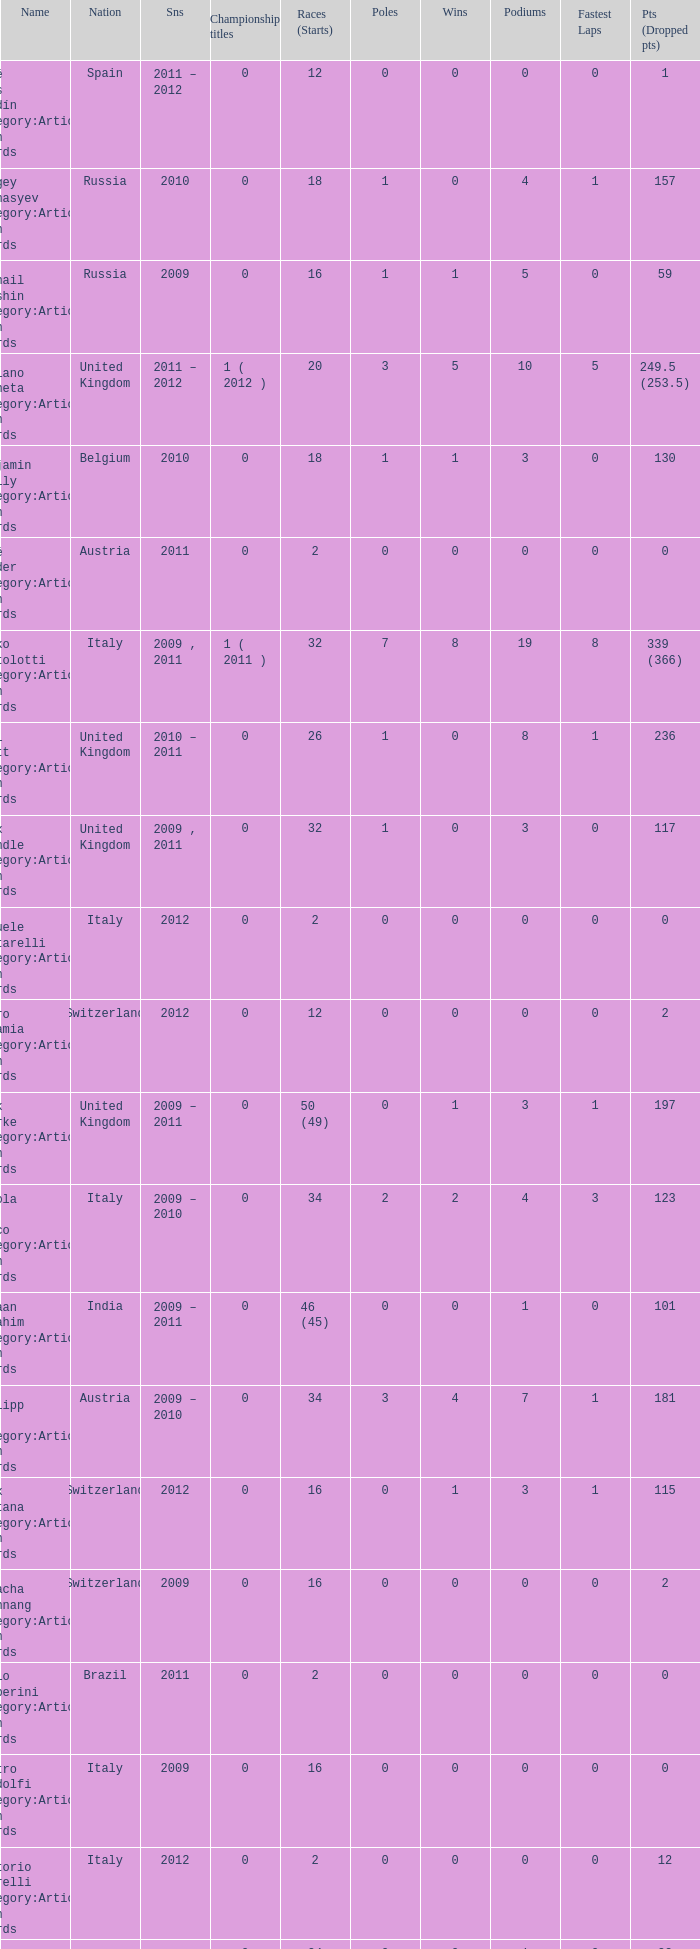What is the minimum amount of poles? 0.0. Help me parse the entirety of this table. {'header': ['Name', 'Nation', 'Sns', 'Championship titles', 'Races (Starts)', 'Poles', 'Wins', 'Podiums', 'Fastest Laps', 'Pts (Dropped pts)'], 'rows': [['José Luis Abadín Category:Articles with hCards', 'Spain', '2011 – 2012', '0', '12', '0', '0', '0', '0', '1'], ['Sergey Afanasyev Category:Articles with hCards', 'Russia', '2010', '0', '18', '1', '0', '4', '1', '157'], ['Mikhail Aleshin Category:Articles with hCards', 'Russia', '2009', '0', '16', '1', '1', '5', '0', '59'], ['Luciano Bacheta Category:Articles with hCards', 'United Kingdom', '2011 – 2012', '1 ( 2012 )', '20', '3', '5', '10', '5', '249.5 (253.5)'], ['Benjamin Bailly Category:Articles with hCards', 'Belgium', '2010', '0', '18', '1', '1', '3', '0', '130'], ['René Binder Category:Articles with hCards', 'Austria', '2011', '0', '2', '0', '0', '0', '0', '0'], ['Mirko Bortolotti Category:Articles with hCards', 'Italy', '2009 , 2011', '1 ( 2011 )', '32', '7', '8', '19', '8', '339 (366)'], ['Will Bratt Category:Articles with hCards', 'United Kingdom', '2010 – 2011', '0', '26', '1', '0', '8', '1', '236'], ['Alex Brundle Category:Articles with hCards', 'United Kingdom', '2009 , 2011', '0', '32', '1', '0', '3', '0', '117'], ['Samuele Buttarelli Category:Articles with hCards', 'Italy', '2012', '0', '2', '0', '0', '0', '0', '0'], ['Mauro Calamia Category:Articles with hCards', 'Switzerland', '2012', '0', '12', '0', '0', '0', '0', '2'], ['Jack Clarke Category:Articles with hCards', 'United Kingdom', '2009 – 2011', '0', '50 (49)', '0', '1', '3', '1', '197'], ['Nicola de Marco Category:Articles with hCards', 'Italy', '2009 – 2010', '0', '34', '2', '2', '4', '3', '123'], ['Armaan Ebrahim Category:Articles with hCards', 'India', '2009 – 2011', '0', '46 (45)', '0', '0', '1', '0', '101'], ['Philipp Eng Category:Articles with hCards', 'Austria', '2009 – 2010', '0', '34', '3', '4', '7', '1', '181'], ['Alex Fontana Category:Articles with hCards', 'Switzerland', '2012', '0', '16', '0', '1', '3', '1', '115'], ['Natacha Gachnang Category:Articles with hCards', 'Switzerland', '2009', '0', '16', '0', '0', '0', '0', '2'], ['Fabio Gamberini Category:Articles with hCards', 'Brazil', '2011', '0', '2', '0', '0', '0', '0', '0'], ['Pietro Gandolfi Category:Articles with hCards', 'Italy', '2009', '0', '16', '0', '0', '0', '0', '0'], ['Vittorio Ghirelli Category:Articles with hCards', 'Italy', '2012', '0', '2', '0', '0', '0', '0', '12'], ['Tom Gladdis Category:Articles with hCards', 'United Kingdom', '2009 – 2011', '0', '24', '0', '0', '1', '0', '33'], ['Richard Gonda Category:Articles with hCards', 'Slovakia', '2012', '0', '2', '0', '0', '0', '0', '4'], ['Victor Guerin Category:Articles with hCards', 'Brazil', '2012', '0', '2', '0', '0', '0', '0', '2'], ['Ollie Hancock Category:Articles with hCards', 'United Kingdom', '2009', '0', '6', '0', '0', '0', '0', '0'], ['Tobias Hegewald Category:Articles with hCards', 'Germany', '2009 , 2011', '0', '32', '4', '2', '5', '3', '158'], ['Sebastian Hohenthal Category:Articles with hCards', 'Sweden', '2009', '0', '16', '0', '0', '0', '0', '7'], ['Jens Höing Category:Articles with hCards', 'Germany', '2009', '0', '16', '0', '0', '0', '0', '0'], ['Hector Hurst Category:Articles with hCards', 'United Kingdom', '2012', '0', '16', '0', '0', '0', '0', '27'], ['Carlos Iaconelli Category:Articles with hCards', 'Brazil', '2009', '0', '14', '0', '0', '1', '0', '21'], ['Axcil Jefferies Category:Articles with hCards', 'Zimbabwe', '2012', '0', '12 (11)', '0', '0', '0', '0', '17'], ['Johan Jokinen Category:Articles with hCards', 'Denmark', '2010', '0', '6', '0', '0', '1', '1', '21'], ['Julien Jousse Category:Articles with hCards', 'France', '2009', '0', '16', '1', '1', '4', '2', '49'], ['Henri Karjalainen Category:Articles with hCards', 'Finland', '2009', '0', '16', '0', '0', '0', '0', '7'], ['Kourosh Khani Category:Articles with hCards', 'Iran', '2012', '0', '8', '0', '0', '0', '0', '2'], ['Jordan King Category:Articles with hCards', 'United Kingdom', '2011', '0', '6', '0', '0', '0', '0', '17'], ['Natalia Kowalska Category:Articles with hCards', 'Poland', '2010 – 2011', '0', '20', '0', '0', '0', '0', '3'], ['Plamen Kralev Category:Articles with hCards', 'Bulgaria', '2010 – 2012', '0', '50 (49)', '0', '0', '0', '0', '6'], ['Ajith Kumar Category:Articles with hCards', 'India', '2010', '0', '6', '0', '0', '0', '0', '0'], ['Jon Lancaster Category:Articles with hCards', 'United Kingdom', '2011', '0', '2', '0', '0', '0', '0', '14'], ['Benjamin Lariche Category:Articles with hCards', 'France', '2010 – 2011', '0', '34', '0', '0', '0', '0', '48'], ['Mikkel Mac Category:Articles with hCards', 'Denmark', '2011', '0', '16', '0', '0', '0', '0', '23'], ['Mihai Marinescu Category:Articles with hCards', 'Romania', '2010 – 2012', '0', '50', '4', '3', '8', '4', '299'], ['Daniel McKenzie Category:Articles with hCards', 'United Kingdom', '2012', '0', '16', '0', '0', '2', '0', '95'], ['Kevin Mirocha Category:Articles with hCards', 'Poland', '2012', '0', '16', '1', '1', '6', '0', '159.5'], ['Miki Monrás Category:Articles with hCards', 'Spain', '2011', '0', '16', '1', '1', '4', '1', '153'], ['Jason Moore Category:Articles with hCards', 'United Kingdom', '2009', '0', '16 (15)', '0', '0', '0', '0', '3'], ['Sung-Hak Mun Category:Articles with hCards', 'South Korea', '2011', '0', '16 (15)', '0', '0', '0', '0', '0'], ['Jolyon Palmer Category:Articles with hCards', 'United Kingdom', '2009 – 2010', '0', '34 (36)', '5', '5', '10', '3', '245'], ['Miloš Pavlović Category:Articles with hCards', 'Serbia', '2009', '0', '16', '0', '0', '2', '1', '29'], ['Ramón Piñeiro Category:Articles with hCards', 'Spain', '2010 – 2011', '0', '18', '2', '3', '7', '2', '186'], ['Markus Pommer Category:Articles with hCards', 'Germany', '2012', '0', '16', '4', '3', '5', '2', '169'], ['Edoardo Piscopo Category:Articles with hCards', 'Italy', '2009', '0', '14', '0', '0', '0', '0', '19'], ['Paul Rees Category:Articles with hCards', 'United Kingdom', '2010', '0', '8', '0', '0', '0', '0', '18'], ['Ivan Samarin Category:Articles with hCards', 'Russia', '2010', '0', '18', '0', '0', '0', '0', '64'], ['Germán Sánchez Category:Articles with hCards', 'Spain', '2009', '0', '16 (14)', '0', '0', '0', '0', '2'], ['Harald Schlegelmilch Category:Articles with hCards', 'Latvia', '2012', '0', '2', '0', '0', '0', '0', '12'], ['Max Snegirev Category:Articles with hCards', 'Russia', '2011 – 2012', '0', '28', '0', '0', '0', '0', '20'], ['Kelvin Snoeks Category:Articles with hCards', 'Netherlands', '2010 – 2011', '0', '32', '0', '0', '1', '0', '88'], ['Andy Soucek Category:Articles with hCards', 'Spain', '2009', '1 ( 2009 )', '16', '2', '7', '11', '3', '115'], ['Dean Stoneman Category:Articles with hCards', 'United Kingdom', '2010', '1 ( 2010 )', '18', '6', '6', '13', '6', '284'], ['Thiemo Storz Category:Articles with hCards', 'Germany', '2011', '0', '16', '0', '0', '0', '0', '19'], ['Parthiva Sureshwaren Category:Articles with hCards', 'India', '2010 – 2012', '0', '32 (31)', '0', '0', '0', '0', '1'], ['Henry Surtees Category:Articles with hCards', 'United Kingdom', '2009', '0', '8', '1', '0', '1', '0', '8'], ['Ricardo Teixeira Category:Articles with hCards', 'Angola', '2010', '0', '18', '0', '0', '0', '0', '23'], ['Johannes Theobald Category:Articles with hCards', 'Germany', '2010 – 2011', '0', '14', '0', '0', '0', '0', '1'], ['Julian Theobald Category:Articles with hCards', 'Germany', '2010 – 2011', '0', '18', '0', '0', '0', '0', '8'], ['Mathéo Tuscher Category:Articles with hCards', 'Switzerland', '2012', '0', '16', '4', '2', '9', '1', '210'], ['Tristan Vautier Category:Articles with hCards', 'France', '2009', '0', '2', '0', '0', '1', '0', '9'], ['Kazim Vasiliauskas Category:Articles with hCards', 'Lithuania', '2009 – 2010', '0', '34', '3', '2', '10', '4', '198'], ['Robert Wickens Category:Articles with hCards', 'Canada', '2009', '0', '16', '5', '2', '6', '3', '64'], ['Dino Zamparelli Category:Articles with hCards', 'United Kingdom', '2012', '0', '16', '0', '0', '2', '0', '106.5'], ['Christopher Zanella Category:Articles with hCards', 'Switzerland', '2011 – 2012', '0', '32', '3', '4', '14', '5', '385 (401)']]} 